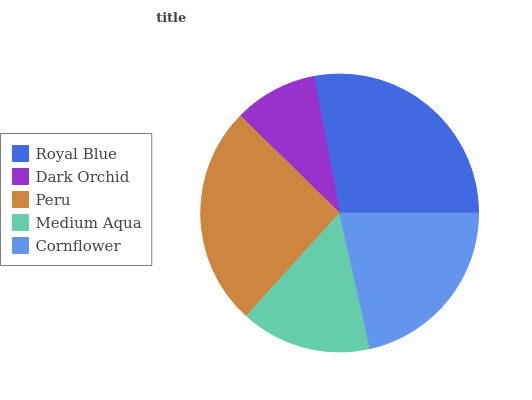Is Dark Orchid the minimum?
Answer yes or no. Yes. Is Royal Blue the maximum?
Answer yes or no. Yes. Is Peru the minimum?
Answer yes or no. No. Is Peru the maximum?
Answer yes or no. No. Is Peru greater than Dark Orchid?
Answer yes or no. Yes. Is Dark Orchid less than Peru?
Answer yes or no. Yes. Is Dark Orchid greater than Peru?
Answer yes or no. No. Is Peru less than Dark Orchid?
Answer yes or no. No. Is Cornflower the high median?
Answer yes or no. Yes. Is Cornflower the low median?
Answer yes or no. Yes. Is Peru the high median?
Answer yes or no. No. Is Royal Blue the low median?
Answer yes or no. No. 